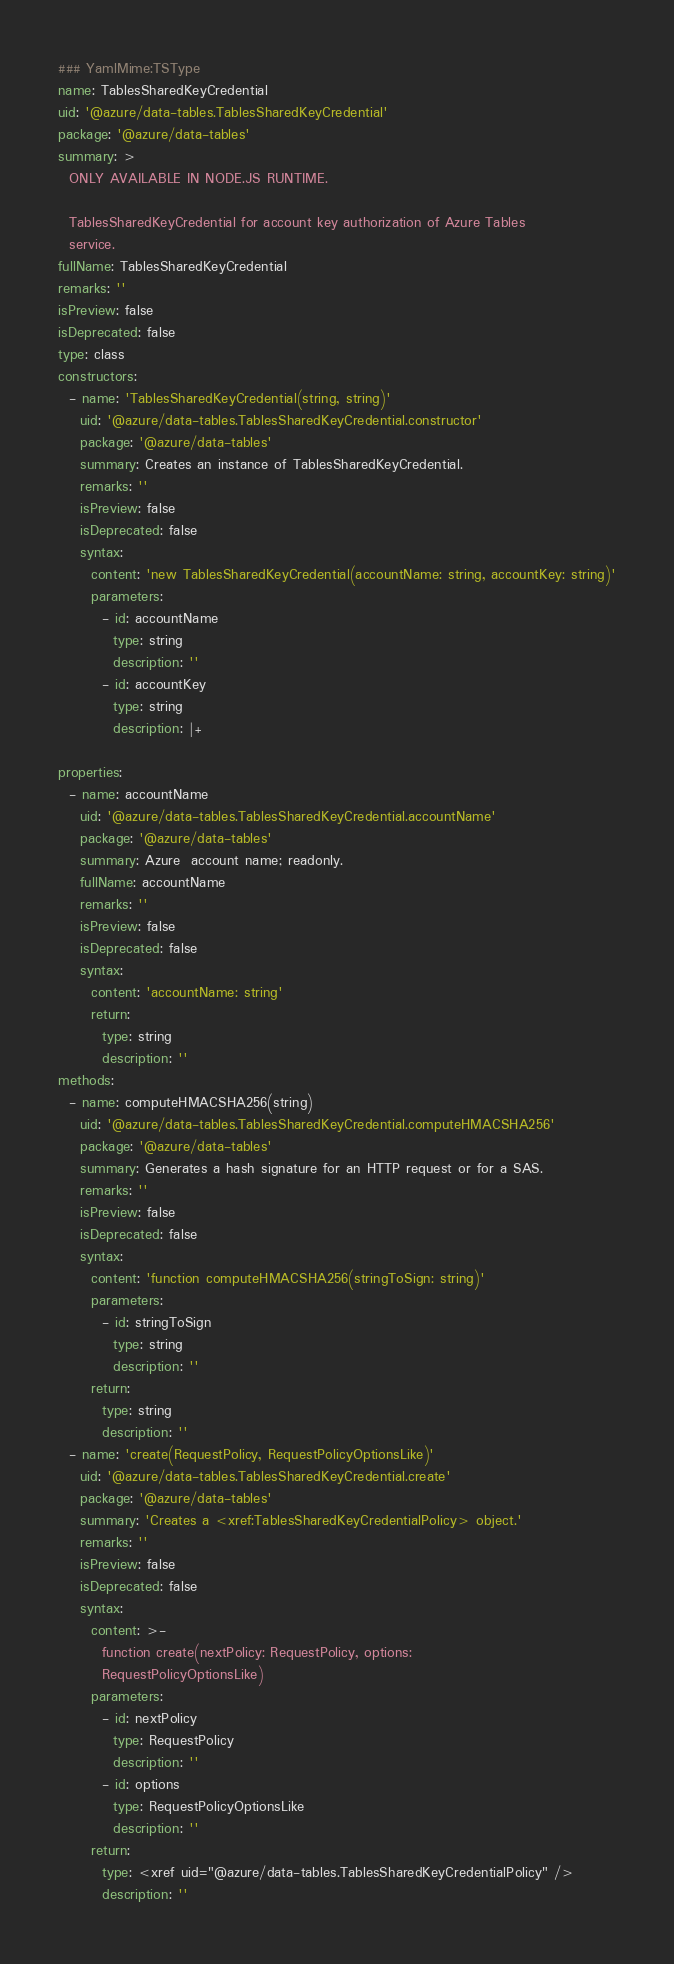Convert code to text. <code><loc_0><loc_0><loc_500><loc_500><_YAML_>### YamlMime:TSType
name: TablesSharedKeyCredential
uid: '@azure/data-tables.TablesSharedKeyCredential'
package: '@azure/data-tables'
summary: >
  ONLY AVAILABLE IN NODE.JS RUNTIME.

  TablesSharedKeyCredential for account key authorization of Azure Tables
  service.
fullName: TablesSharedKeyCredential
remarks: ''
isPreview: false
isDeprecated: false
type: class
constructors:
  - name: 'TablesSharedKeyCredential(string, string)'
    uid: '@azure/data-tables.TablesSharedKeyCredential.constructor'
    package: '@azure/data-tables'
    summary: Creates an instance of TablesSharedKeyCredential.
    remarks: ''
    isPreview: false
    isDeprecated: false
    syntax:
      content: 'new TablesSharedKeyCredential(accountName: string, accountKey: string)'
      parameters:
        - id: accountName
          type: string
          description: ''
        - id: accountKey
          type: string
          description: |+

properties:
  - name: accountName
    uid: '@azure/data-tables.TablesSharedKeyCredential.accountName'
    package: '@azure/data-tables'
    summary: Azure  account name; readonly.
    fullName: accountName
    remarks: ''
    isPreview: false
    isDeprecated: false
    syntax:
      content: 'accountName: string'
      return:
        type: string
        description: ''
methods:
  - name: computeHMACSHA256(string)
    uid: '@azure/data-tables.TablesSharedKeyCredential.computeHMACSHA256'
    package: '@azure/data-tables'
    summary: Generates a hash signature for an HTTP request or for a SAS.
    remarks: ''
    isPreview: false
    isDeprecated: false
    syntax:
      content: 'function computeHMACSHA256(stringToSign: string)'
      parameters:
        - id: stringToSign
          type: string
          description: ''
      return:
        type: string
        description: ''
  - name: 'create(RequestPolicy, RequestPolicyOptionsLike)'
    uid: '@azure/data-tables.TablesSharedKeyCredential.create'
    package: '@azure/data-tables'
    summary: 'Creates a <xref:TablesSharedKeyCredentialPolicy> object.'
    remarks: ''
    isPreview: false
    isDeprecated: false
    syntax:
      content: >-
        function create(nextPolicy: RequestPolicy, options:
        RequestPolicyOptionsLike)
      parameters:
        - id: nextPolicy
          type: RequestPolicy
          description: ''
        - id: options
          type: RequestPolicyOptionsLike
          description: ''
      return:
        type: <xref uid="@azure/data-tables.TablesSharedKeyCredentialPolicy" />
        description: ''
</code> 